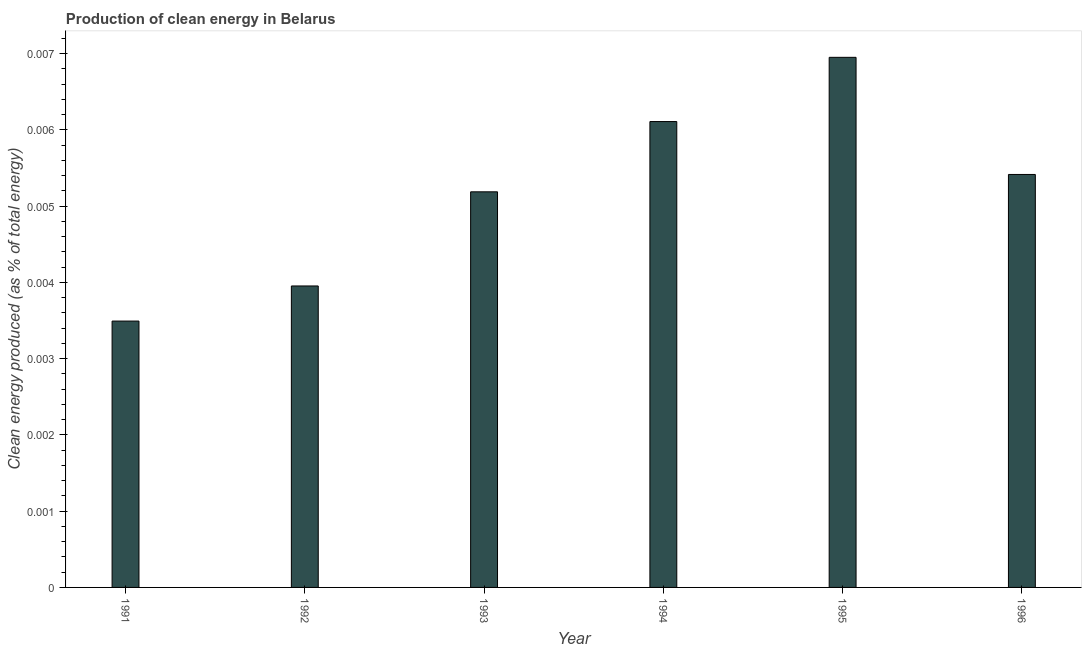Does the graph contain grids?
Offer a very short reply. No. What is the title of the graph?
Give a very brief answer. Production of clean energy in Belarus. What is the label or title of the X-axis?
Your answer should be very brief. Year. What is the label or title of the Y-axis?
Your answer should be compact. Clean energy produced (as % of total energy). What is the production of clean energy in 1992?
Ensure brevity in your answer.  0. Across all years, what is the maximum production of clean energy?
Your response must be concise. 0.01. Across all years, what is the minimum production of clean energy?
Offer a very short reply. 0. In which year was the production of clean energy maximum?
Offer a terse response. 1995. What is the sum of the production of clean energy?
Offer a very short reply. 0.03. What is the difference between the production of clean energy in 1991 and 1994?
Provide a succinct answer. -0. What is the average production of clean energy per year?
Ensure brevity in your answer.  0.01. What is the median production of clean energy?
Keep it short and to the point. 0.01. In how many years, is the production of clean energy greater than 0.0066 %?
Provide a short and direct response. 1. Do a majority of the years between 1992 and 1996 (inclusive) have production of clean energy greater than 0.005 %?
Make the answer very short. Yes. What is the ratio of the production of clean energy in 1992 to that in 1993?
Provide a succinct answer. 0.76. Is the production of clean energy in 1992 less than that in 1995?
Provide a succinct answer. Yes. Is the difference between the production of clean energy in 1991 and 1994 greater than the difference between any two years?
Make the answer very short. No. What is the difference between the highest and the second highest production of clean energy?
Your answer should be very brief. 0. What is the difference between the highest and the lowest production of clean energy?
Provide a short and direct response. 0. In how many years, is the production of clean energy greater than the average production of clean energy taken over all years?
Your answer should be compact. 4. How many years are there in the graph?
Your answer should be very brief. 6. Are the values on the major ticks of Y-axis written in scientific E-notation?
Provide a succinct answer. No. What is the Clean energy produced (as % of total energy) in 1991?
Your answer should be very brief. 0. What is the Clean energy produced (as % of total energy) in 1992?
Give a very brief answer. 0. What is the Clean energy produced (as % of total energy) in 1993?
Your answer should be very brief. 0.01. What is the Clean energy produced (as % of total energy) in 1994?
Offer a very short reply. 0.01. What is the Clean energy produced (as % of total energy) of 1995?
Provide a short and direct response. 0.01. What is the Clean energy produced (as % of total energy) in 1996?
Keep it short and to the point. 0.01. What is the difference between the Clean energy produced (as % of total energy) in 1991 and 1992?
Give a very brief answer. -0. What is the difference between the Clean energy produced (as % of total energy) in 1991 and 1993?
Your answer should be compact. -0. What is the difference between the Clean energy produced (as % of total energy) in 1991 and 1994?
Provide a short and direct response. -0. What is the difference between the Clean energy produced (as % of total energy) in 1991 and 1995?
Make the answer very short. -0. What is the difference between the Clean energy produced (as % of total energy) in 1991 and 1996?
Your answer should be compact. -0. What is the difference between the Clean energy produced (as % of total energy) in 1992 and 1993?
Your answer should be compact. -0. What is the difference between the Clean energy produced (as % of total energy) in 1992 and 1994?
Offer a very short reply. -0. What is the difference between the Clean energy produced (as % of total energy) in 1992 and 1995?
Your response must be concise. -0. What is the difference between the Clean energy produced (as % of total energy) in 1992 and 1996?
Your answer should be very brief. -0. What is the difference between the Clean energy produced (as % of total energy) in 1993 and 1994?
Offer a terse response. -0. What is the difference between the Clean energy produced (as % of total energy) in 1993 and 1995?
Offer a very short reply. -0. What is the difference between the Clean energy produced (as % of total energy) in 1993 and 1996?
Make the answer very short. -0. What is the difference between the Clean energy produced (as % of total energy) in 1994 and 1995?
Provide a short and direct response. -0. What is the difference between the Clean energy produced (as % of total energy) in 1994 and 1996?
Ensure brevity in your answer.  0. What is the difference between the Clean energy produced (as % of total energy) in 1995 and 1996?
Ensure brevity in your answer.  0. What is the ratio of the Clean energy produced (as % of total energy) in 1991 to that in 1992?
Give a very brief answer. 0.88. What is the ratio of the Clean energy produced (as % of total energy) in 1991 to that in 1993?
Make the answer very short. 0.67. What is the ratio of the Clean energy produced (as % of total energy) in 1991 to that in 1994?
Give a very brief answer. 0.57. What is the ratio of the Clean energy produced (as % of total energy) in 1991 to that in 1995?
Your answer should be compact. 0.5. What is the ratio of the Clean energy produced (as % of total energy) in 1991 to that in 1996?
Offer a very short reply. 0.65. What is the ratio of the Clean energy produced (as % of total energy) in 1992 to that in 1993?
Your response must be concise. 0.76. What is the ratio of the Clean energy produced (as % of total energy) in 1992 to that in 1994?
Offer a terse response. 0.65. What is the ratio of the Clean energy produced (as % of total energy) in 1992 to that in 1995?
Offer a very short reply. 0.57. What is the ratio of the Clean energy produced (as % of total energy) in 1992 to that in 1996?
Your response must be concise. 0.73. What is the ratio of the Clean energy produced (as % of total energy) in 1993 to that in 1994?
Provide a succinct answer. 0.85. What is the ratio of the Clean energy produced (as % of total energy) in 1993 to that in 1995?
Keep it short and to the point. 0.75. What is the ratio of the Clean energy produced (as % of total energy) in 1993 to that in 1996?
Keep it short and to the point. 0.96. What is the ratio of the Clean energy produced (as % of total energy) in 1994 to that in 1995?
Give a very brief answer. 0.88. What is the ratio of the Clean energy produced (as % of total energy) in 1994 to that in 1996?
Make the answer very short. 1.13. What is the ratio of the Clean energy produced (as % of total energy) in 1995 to that in 1996?
Provide a succinct answer. 1.28. 